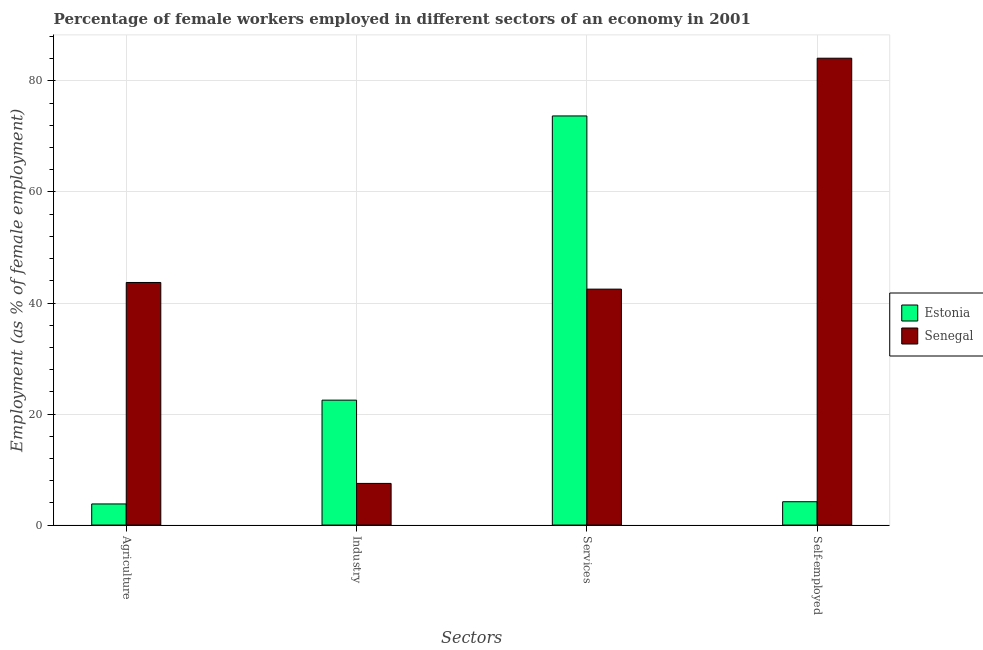How many different coloured bars are there?
Your answer should be very brief. 2. Are the number of bars per tick equal to the number of legend labels?
Ensure brevity in your answer.  Yes. What is the label of the 4th group of bars from the left?
Keep it short and to the point. Self-employed. What is the percentage of female workers in industry in Senegal?
Your response must be concise. 7.5. Across all countries, what is the maximum percentage of female workers in services?
Your answer should be compact. 73.7. Across all countries, what is the minimum percentage of self employed female workers?
Your response must be concise. 4.2. In which country was the percentage of female workers in services maximum?
Give a very brief answer. Estonia. In which country was the percentage of female workers in agriculture minimum?
Provide a short and direct response. Estonia. What is the total percentage of female workers in services in the graph?
Give a very brief answer. 116.2. What is the difference between the percentage of female workers in industry in Estonia and that in Senegal?
Your answer should be compact. 15. What is the difference between the percentage of self employed female workers in Senegal and the percentage of female workers in services in Estonia?
Offer a very short reply. 10.4. What is the average percentage of female workers in agriculture per country?
Make the answer very short. 23.75. What is the difference between the percentage of self employed female workers and percentage of female workers in industry in Senegal?
Your answer should be compact. 76.6. In how many countries, is the percentage of self employed female workers greater than 64 %?
Ensure brevity in your answer.  1. What is the ratio of the percentage of self employed female workers in Estonia to that in Senegal?
Offer a terse response. 0.05. Is the percentage of self employed female workers in Estonia less than that in Senegal?
Provide a succinct answer. Yes. Is the difference between the percentage of female workers in services in Estonia and Senegal greater than the difference between the percentage of self employed female workers in Estonia and Senegal?
Offer a terse response. Yes. What is the difference between the highest and the lowest percentage of female workers in services?
Keep it short and to the point. 31.2. In how many countries, is the percentage of female workers in agriculture greater than the average percentage of female workers in agriculture taken over all countries?
Ensure brevity in your answer.  1. Is the sum of the percentage of female workers in services in Senegal and Estonia greater than the maximum percentage of female workers in agriculture across all countries?
Ensure brevity in your answer.  Yes. What does the 2nd bar from the left in Self-employed represents?
Provide a succinct answer. Senegal. What does the 2nd bar from the right in Services represents?
Give a very brief answer. Estonia. How many bars are there?
Your answer should be very brief. 8. Are all the bars in the graph horizontal?
Keep it short and to the point. No. Does the graph contain any zero values?
Keep it short and to the point. No. What is the title of the graph?
Ensure brevity in your answer.  Percentage of female workers employed in different sectors of an economy in 2001. Does "Guam" appear as one of the legend labels in the graph?
Your answer should be compact. No. What is the label or title of the X-axis?
Make the answer very short. Sectors. What is the label or title of the Y-axis?
Your answer should be very brief. Employment (as % of female employment). What is the Employment (as % of female employment) of Estonia in Agriculture?
Provide a short and direct response. 3.8. What is the Employment (as % of female employment) of Senegal in Agriculture?
Make the answer very short. 43.7. What is the Employment (as % of female employment) in Estonia in Industry?
Offer a very short reply. 22.5. What is the Employment (as % of female employment) of Estonia in Services?
Make the answer very short. 73.7. What is the Employment (as % of female employment) of Senegal in Services?
Offer a very short reply. 42.5. What is the Employment (as % of female employment) of Estonia in Self-employed?
Offer a very short reply. 4.2. What is the Employment (as % of female employment) of Senegal in Self-employed?
Offer a terse response. 84.1. Across all Sectors, what is the maximum Employment (as % of female employment) of Estonia?
Give a very brief answer. 73.7. Across all Sectors, what is the maximum Employment (as % of female employment) of Senegal?
Your response must be concise. 84.1. Across all Sectors, what is the minimum Employment (as % of female employment) in Estonia?
Your response must be concise. 3.8. What is the total Employment (as % of female employment) in Estonia in the graph?
Make the answer very short. 104.2. What is the total Employment (as % of female employment) of Senegal in the graph?
Give a very brief answer. 177.8. What is the difference between the Employment (as % of female employment) in Estonia in Agriculture and that in Industry?
Provide a succinct answer. -18.7. What is the difference between the Employment (as % of female employment) of Senegal in Agriculture and that in Industry?
Provide a succinct answer. 36.2. What is the difference between the Employment (as % of female employment) in Estonia in Agriculture and that in Services?
Offer a very short reply. -69.9. What is the difference between the Employment (as % of female employment) in Senegal in Agriculture and that in Services?
Offer a terse response. 1.2. What is the difference between the Employment (as % of female employment) of Estonia in Agriculture and that in Self-employed?
Ensure brevity in your answer.  -0.4. What is the difference between the Employment (as % of female employment) of Senegal in Agriculture and that in Self-employed?
Provide a succinct answer. -40.4. What is the difference between the Employment (as % of female employment) of Estonia in Industry and that in Services?
Ensure brevity in your answer.  -51.2. What is the difference between the Employment (as % of female employment) of Senegal in Industry and that in Services?
Give a very brief answer. -35. What is the difference between the Employment (as % of female employment) of Senegal in Industry and that in Self-employed?
Your answer should be compact. -76.6. What is the difference between the Employment (as % of female employment) of Estonia in Services and that in Self-employed?
Your answer should be very brief. 69.5. What is the difference between the Employment (as % of female employment) of Senegal in Services and that in Self-employed?
Your answer should be compact. -41.6. What is the difference between the Employment (as % of female employment) of Estonia in Agriculture and the Employment (as % of female employment) of Senegal in Industry?
Keep it short and to the point. -3.7. What is the difference between the Employment (as % of female employment) in Estonia in Agriculture and the Employment (as % of female employment) in Senegal in Services?
Keep it short and to the point. -38.7. What is the difference between the Employment (as % of female employment) in Estonia in Agriculture and the Employment (as % of female employment) in Senegal in Self-employed?
Ensure brevity in your answer.  -80.3. What is the difference between the Employment (as % of female employment) of Estonia in Industry and the Employment (as % of female employment) of Senegal in Self-employed?
Provide a succinct answer. -61.6. What is the difference between the Employment (as % of female employment) of Estonia in Services and the Employment (as % of female employment) of Senegal in Self-employed?
Provide a succinct answer. -10.4. What is the average Employment (as % of female employment) in Estonia per Sectors?
Make the answer very short. 26.05. What is the average Employment (as % of female employment) in Senegal per Sectors?
Provide a succinct answer. 44.45. What is the difference between the Employment (as % of female employment) of Estonia and Employment (as % of female employment) of Senegal in Agriculture?
Keep it short and to the point. -39.9. What is the difference between the Employment (as % of female employment) in Estonia and Employment (as % of female employment) in Senegal in Services?
Offer a terse response. 31.2. What is the difference between the Employment (as % of female employment) in Estonia and Employment (as % of female employment) in Senegal in Self-employed?
Offer a terse response. -79.9. What is the ratio of the Employment (as % of female employment) in Estonia in Agriculture to that in Industry?
Provide a succinct answer. 0.17. What is the ratio of the Employment (as % of female employment) of Senegal in Agriculture to that in Industry?
Ensure brevity in your answer.  5.83. What is the ratio of the Employment (as % of female employment) of Estonia in Agriculture to that in Services?
Offer a very short reply. 0.05. What is the ratio of the Employment (as % of female employment) of Senegal in Agriculture to that in Services?
Give a very brief answer. 1.03. What is the ratio of the Employment (as % of female employment) in Estonia in Agriculture to that in Self-employed?
Provide a succinct answer. 0.9. What is the ratio of the Employment (as % of female employment) in Senegal in Agriculture to that in Self-employed?
Offer a terse response. 0.52. What is the ratio of the Employment (as % of female employment) of Estonia in Industry to that in Services?
Keep it short and to the point. 0.31. What is the ratio of the Employment (as % of female employment) in Senegal in Industry to that in Services?
Keep it short and to the point. 0.18. What is the ratio of the Employment (as % of female employment) of Estonia in Industry to that in Self-employed?
Ensure brevity in your answer.  5.36. What is the ratio of the Employment (as % of female employment) in Senegal in Industry to that in Self-employed?
Your answer should be compact. 0.09. What is the ratio of the Employment (as % of female employment) of Estonia in Services to that in Self-employed?
Give a very brief answer. 17.55. What is the ratio of the Employment (as % of female employment) of Senegal in Services to that in Self-employed?
Ensure brevity in your answer.  0.51. What is the difference between the highest and the second highest Employment (as % of female employment) in Estonia?
Ensure brevity in your answer.  51.2. What is the difference between the highest and the second highest Employment (as % of female employment) of Senegal?
Provide a short and direct response. 40.4. What is the difference between the highest and the lowest Employment (as % of female employment) in Estonia?
Offer a very short reply. 69.9. What is the difference between the highest and the lowest Employment (as % of female employment) in Senegal?
Keep it short and to the point. 76.6. 